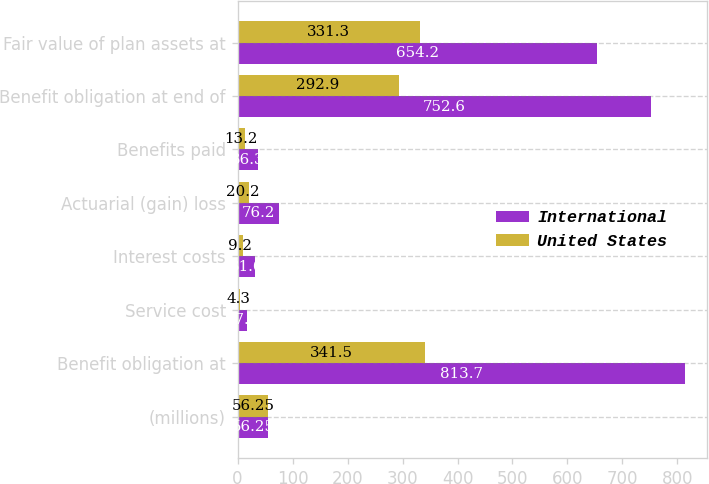Convert chart to OTSL. <chart><loc_0><loc_0><loc_500><loc_500><stacked_bar_chart><ecel><fcel>(millions)<fcel>Benefit obligation at<fcel>Service cost<fcel>Interest costs<fcel>Actuarial (gain) loss<fcel>Benefits paid<fcel>Benefit obligation at end of<fcel>Fair value of plan assets at<nl><fcel>International<fcel>56.25<fcel>813.7<fcel>17<fcel>31.6<fcel>76.2<fcel>36.3<fcel>752.6<fcel>654.2<nl><fcel>United States<fcel>56.25<fcel>341.5<fcel>4.3<fcel>9.2<fcel>20.2<fcel>13.2<fcel>292.9<fcel>331.3<nl></chart> 